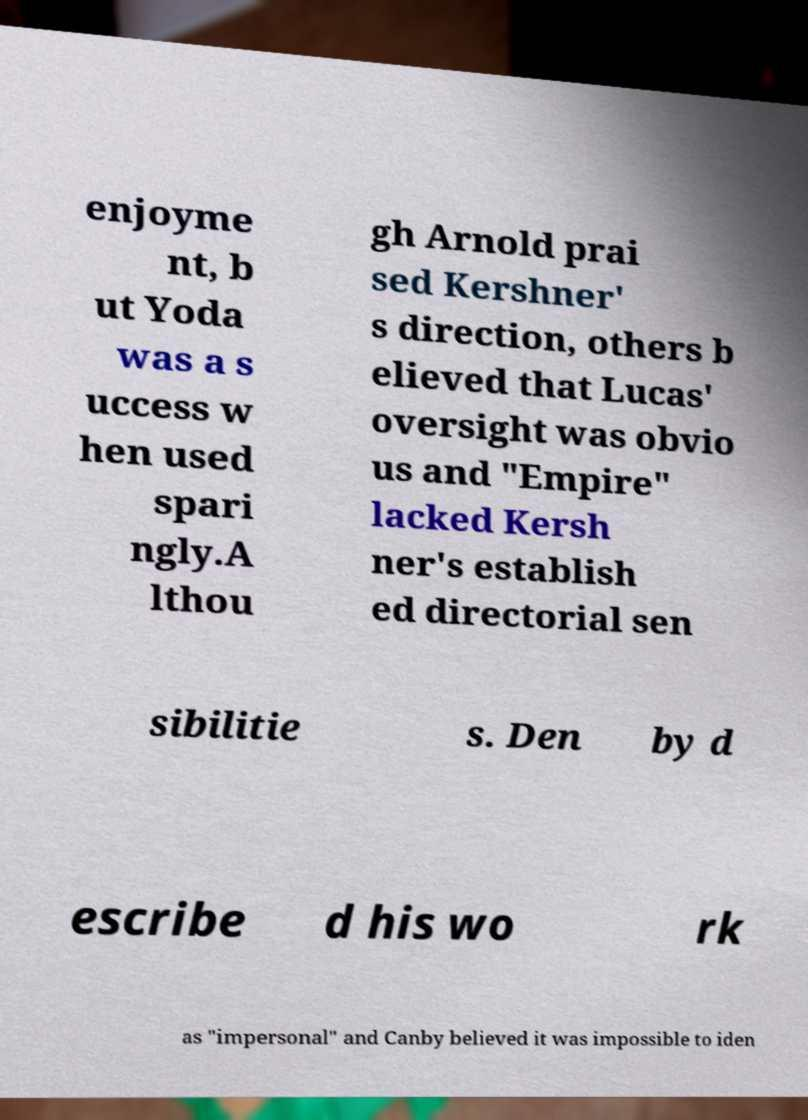Please identify and transcribe the text found in this image. enjoyme nt, b ut Yoda was a s uccess w hen used spari ngly.A lthou gh Arnold prai sed Kershner' s direction, others b elieved that Lucas' oversight was obvio us and "Empire" lacked Kersh ner's establish ed directorial sen sibilitie s. Den by d escribe d his wo rk as "impersonal" and Canby believed it was impossible to iden 